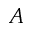<formula> <loc_0><loc_0><loc_500><loc_500>A</formula> 